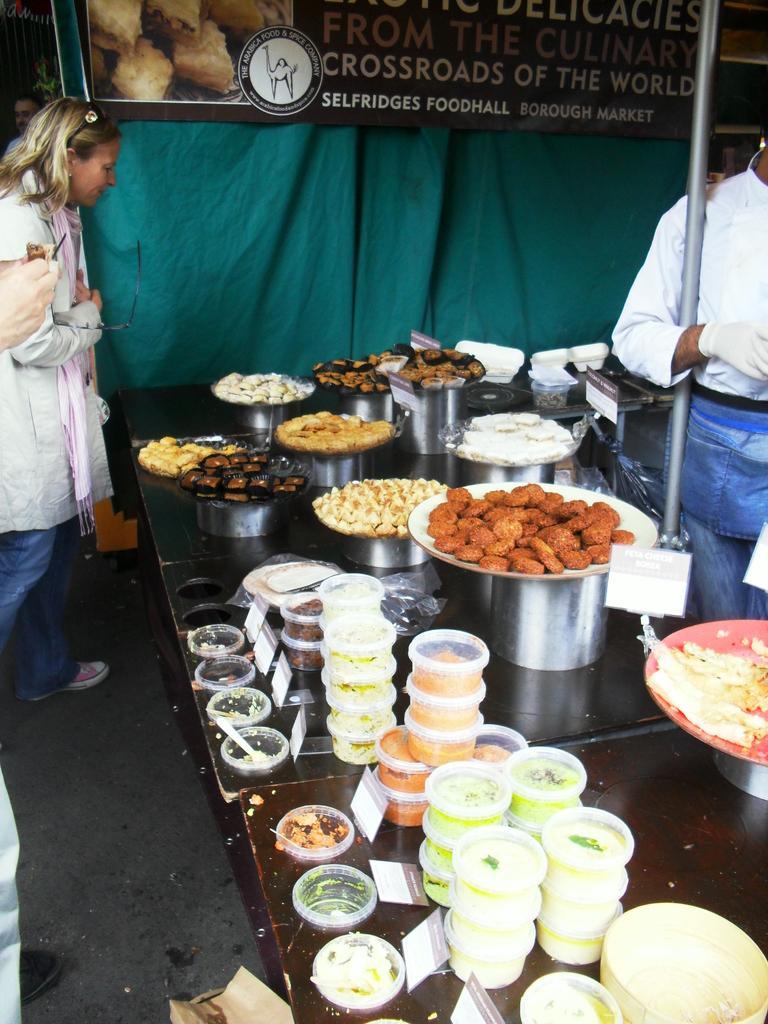Could you give a brief overview of what you see in this image? In this image we can see some people standing. And we can see food items in the containers on the table, on the right we can see a metal pole, in the background we can see curtains, beside that we can see some text written on the board. 